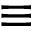<formula> <loc_0><loc_0><loc_500><loc_500>\equiv</formula> 